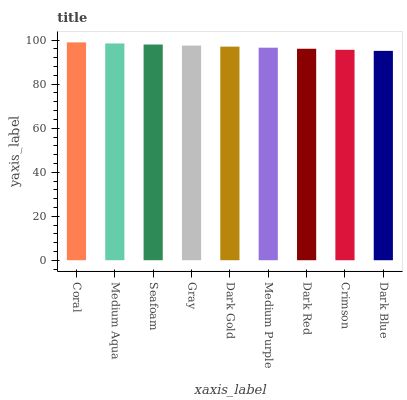Is Medium Aqua the minimum?
Answer yes or no. No. Is Medium Aqua the maximum?
Answer yes or no. No. Is Coral greater than Medium Aqua?
Answer yes or no. Yes. Is Medium Aqua less than Coral?
Answer yes or no. Yes. Is Medium Aqua greater than Coral?
Answer yes or no. No. Is Coral less than Medium Aqua?
Answer yes or no. No. Is Dark Gold the high median?
Answer yes or no. Yes. Is Dark Gold the low median?
Answer yes or no. Yes. Is Gray the high median?
Answer yes or no. No. Is Gray the low median?
Answer yes or no. No. 